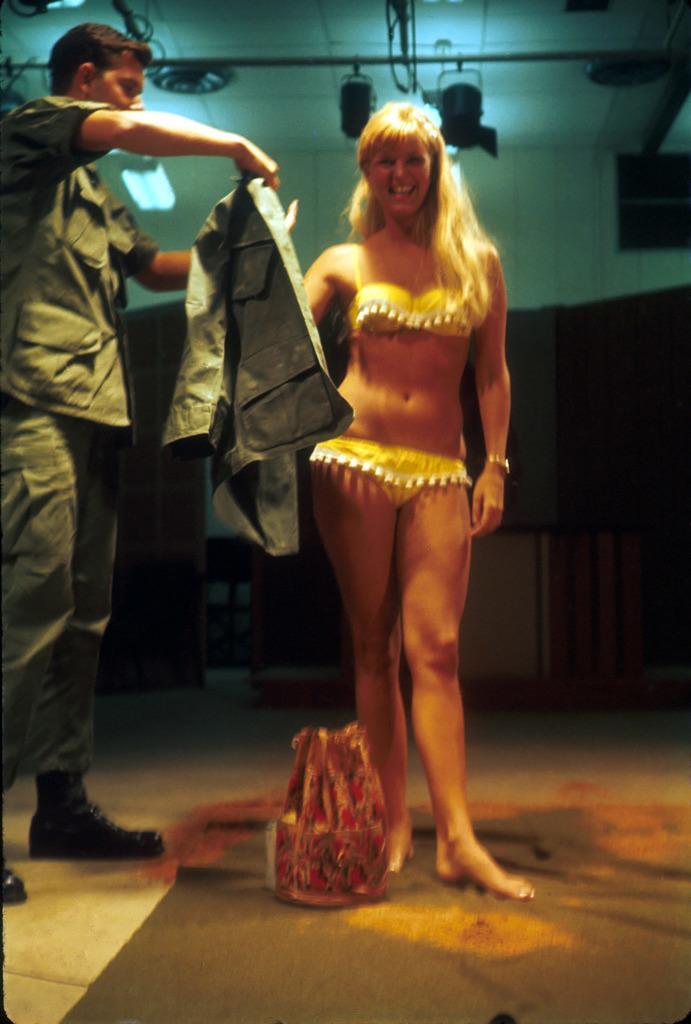Can you describe this image briefly? In this image we can see a lady standing and smiling. On the left there is a man holding a jacket. At the bottom there is a bag placed on the mat. In the background there is a wall and lights. 